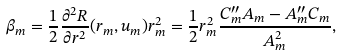<formula> <loc_0><loc_0><loc_500><loc_500>\beta _ { m } = \frac { 1 } { 2 } \frac { \partial ^ { 2 } R } { \partial r ^ { 2 } } ( r _ { m } , u _ { m } ) r _ { m } ^ { 2 } = \frac { 1 } { 2 } r _ { m } ^ { 2 } \frac { C ^ { \prime \prime } _ { m } A _ { m } - A ^ { \prime \prime } _ { m } C _ { m } } { A _ { m } ^ { 2 } } ,</formula> 